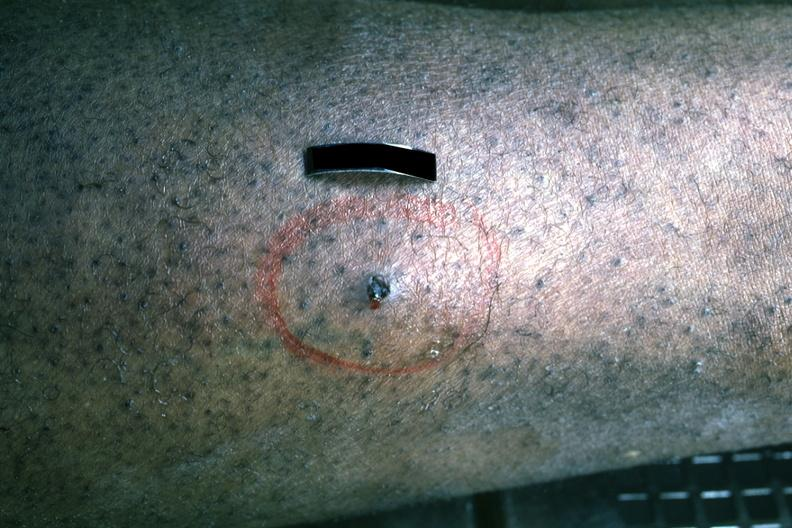what does this image show?
Answer the question using a single word or phrase. Small caliber 